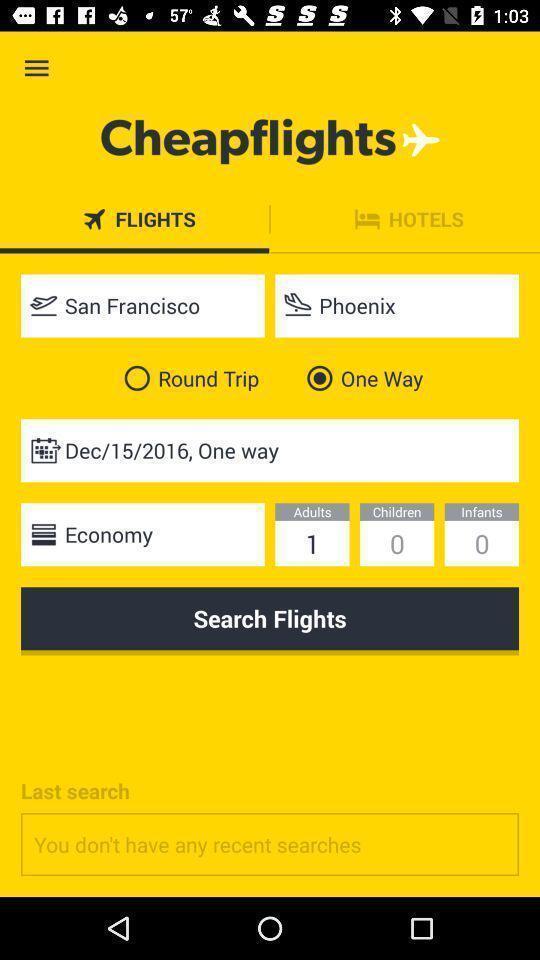Summarize the information in this screenshot. Searching flights in a transport app. 